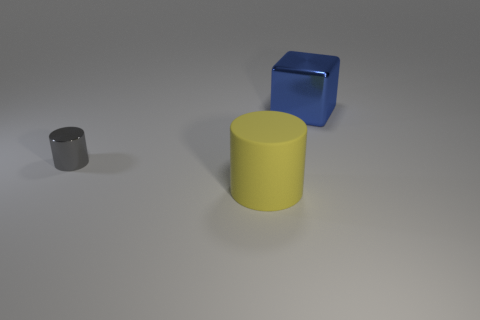What materials do the objects in the image appear to be made of? The objects in the image seem to be made of a matte material with smooth surfaces typical of rubber or plastic, often used for children's toys or educational models. 